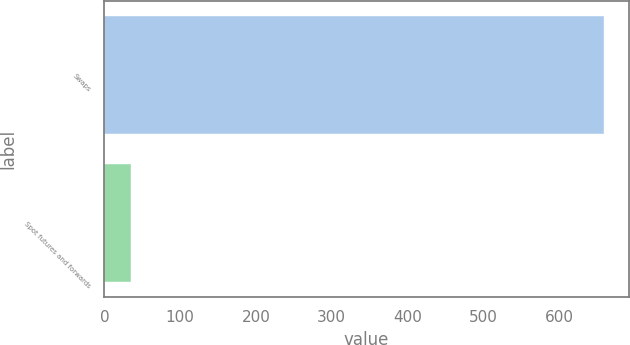Convert chart to OTSL. <chart><loc_0><loc_0><loc_500><loc_500><bar_chart><fcel>Swaps<fcel>Spot futures and forwards<nl><fcel>659.3<fcel>34.6<nl></chart> 